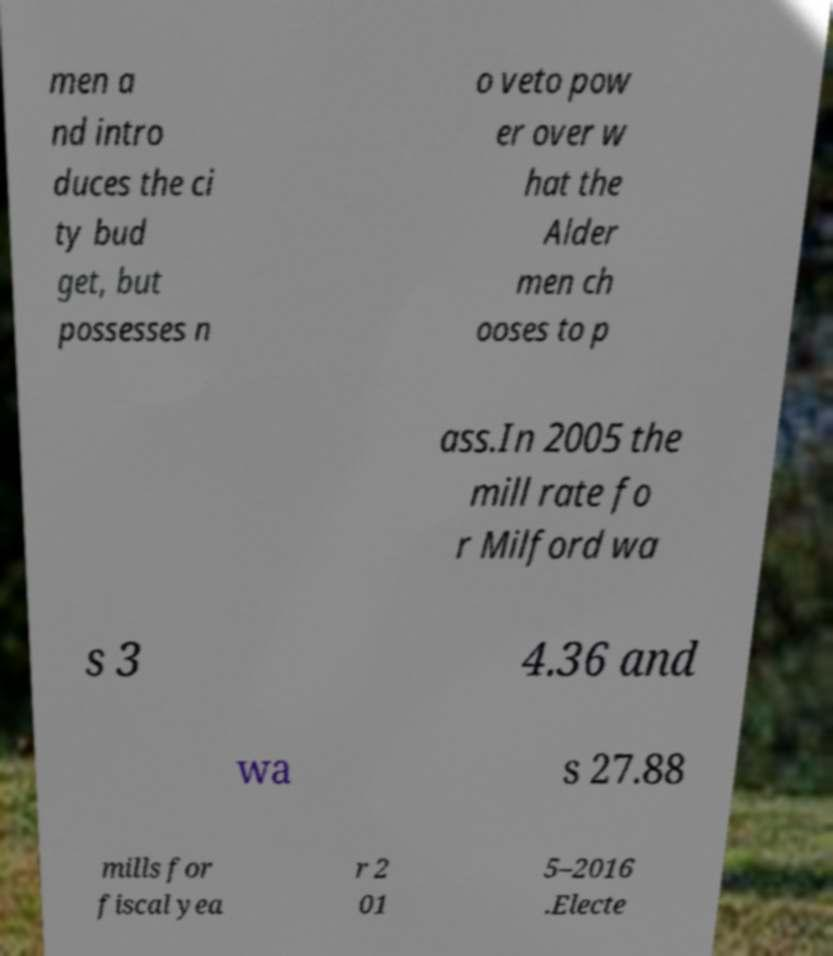What messages or text are displayed in this image? I need them in a readable, typed format. men a nd intro duces the ci ty bud get, but possesses n o veto pow er over w hat the Alder men ch ooses to p ass.In 2005 the mill rate fo r Milford wa s 3 4.36 and wa s 27.88 mills for fiscal yea r 2 01 5–2016 .Electe 